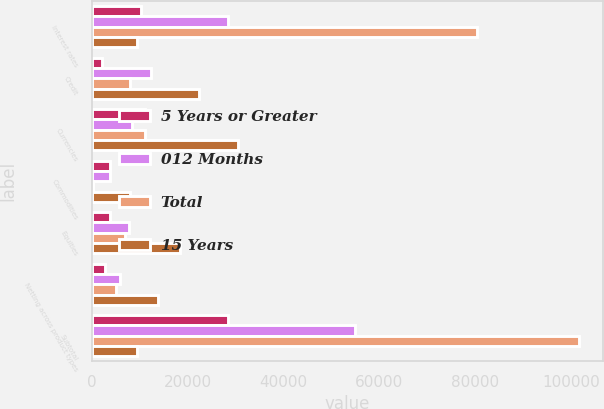Convert chart to OTSL. <chart><loc_0><loc_0><loc_500><loc_500><stacked_bar_chart><ecel><fcel>Interest rates<fcel>Credit<fcel>Currencies<fcel>Commodities<fcel>Equities<fcel>Netting across product types<fcel>Subtotal<nl><fcel>5 Years or Greater<fcel>10318<fcel>2190<fcel>11100<fcel>3840<fcel>3757<fcel>2811<fcel>28394<nl><fcel>012 Months<fcel>28445<fcel>12244<fcel>8379<fcel>3862<fcel>7730<fcel>5831<fcel>54829<nl><fcel>Total<fcel>80449<fcel>7970<fcel>11044<fcel>304<fcel>6957<fcel>5082<fcel>101642<nl><fcel>15 Years<fcel>9348.5<fcel>22404<fcel>30523<fcel>8006<fcel>18444<fcel>13724<fcel>9348.5<nl></chart> 